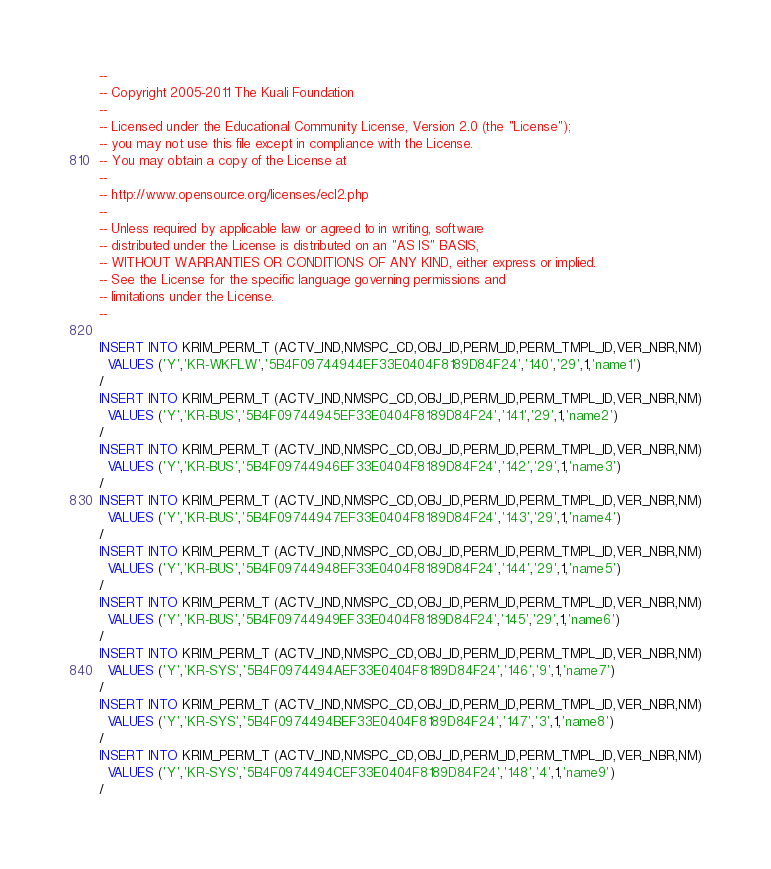Convert code to text. <code><loc_0><loc_0><loc_500><loc_500><_SQL_>--
-- Copyright 2005-2011 The Kuali Foundation
--
-- Licensed under the Educational Community License, Version 2.0 (the "License");
-- you may not use this file except in compliance with the License.
-- You may obtain a copy of the License at
--
-- http://www.opensource.org/licenses/ecl2.php
--
-- Unless required by applicable law or agreed to in writing, software
-- distributed under the License is distributed on an "AS IS" BASIS,
-- WITHOUT WARRANTIES OR CONDITIONS OF ANY KIND, either express or implied.
-- See the License for the specific language governing permissions and
-- limitations under the License.
--

INSERT INTO KRIM_PERM_T (ACTV_IND,NMSPC_CD,OBJ_ID,PERM_ID,PERM_TMPL_ID,VER_NBR,NM)
  VALUES ('Y','KR-WKFLW','5B4F09744944EF33E0404F8189D84F24','140','29',1,'name1')
/
INSERT INTO KRIM_PERM_T (ACTV_IND,NMSPC_CD,OBJ_ID,PERM_ID,PERM_TMPL_ID,VER_NBR,NM)
  VALUES ('Y','KR-BUS','5B4F09744945EF33E0404F8189D84F24','141','29',1,'name2')
/
INSERT INTO KRIM_PERM_T (ACTV_IND,NMSPC_CD,OBJ_ID,PERM_ID,PERM_TMPL_ID,VER_NBR,NM)
  VALUES ('Y','KR-BUS','5B4F09744946EF33E0404F8189D84F24','142','29',1,'name3')
/
INSERT INTO KRIM_PERM_T (ACTV_IND,NMSPC_CD,OBJ_ID,PERM_ID,PERM_TMPL_ID,VER_NBR,NM)
  VALUES ('Y','KR-BUS','5B4F09744947EF33E0404F8189D84F24','143','29',1,'name4')
/
INSERT INTO KRIM_PERM_T (ACTV_IND,NMSPC_CD,OBJ_ID,PERM_ID,PERM_TMPL_ID,VER_NBR,NM)
  VALUES ('Y','KR-BUS','5B4F09744948EF33E0404F8189D84F24','144','29',1,'name5')
/
INSERT INTO KRIM_PERM_T (ACTV_IND,NMSPC_CD,OBJ_ID,PERM_ID,PERM_TMPL_ID,VER_NBR,NM)
  VALUES ('Y','KR-BUS','5B4F09744949EF33E0404F8189D84F24','145','29',1,'name6')
/
INSERT INTO KRIM_PERM_T (ACTV_IND,NMSPC_CD,OBJ_ID,PERM_ID,PERM_TMPL_ID,VER_NBR,NM)
  VALUES ('Y','KR-SYS','5B4F0974494AEF33E0404F8189D84F24','146','9',1,'name7')
/
INSERT INTO KRIM_PERM_T (ACTV_IND,NMSPC_CD,OBJ_ID,PERM_ID,PERM_TMPL_ID,VER_NBR,NM)
  VALUES ('Y','KR-SYS','5B4F0974494BEF33E0404F8189D84F24','147','3',1,'name8')
/
INSERT INTO KRIM_PERM_T (ACTV_IND,NMSPC_CD,OBJ_ID,PERM_ID,PERM_TMPL_ID,VER_NBR,NM)
  VALUES ('Y','KR-SYS','5B4F0974494CEF33E0404F8189D84F24','148','4',1,'name9')
/</code> 